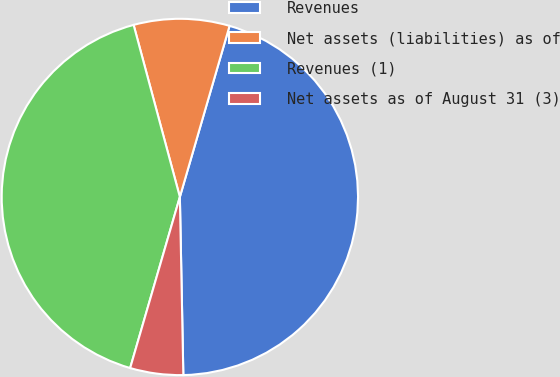Convert chart. <chart><loc_0><loc_0><loc_500><loc_500><pie_chart><fcel>Revenues<fcel>Net assets (liabilities) as of<fcel>Revenues (1)<fcel>Net assets as of August 31 (3)<nl><fcel>45.19%<fcel>8.68%<fcel>41.32%<fcel>4.81%<nl></chart> 